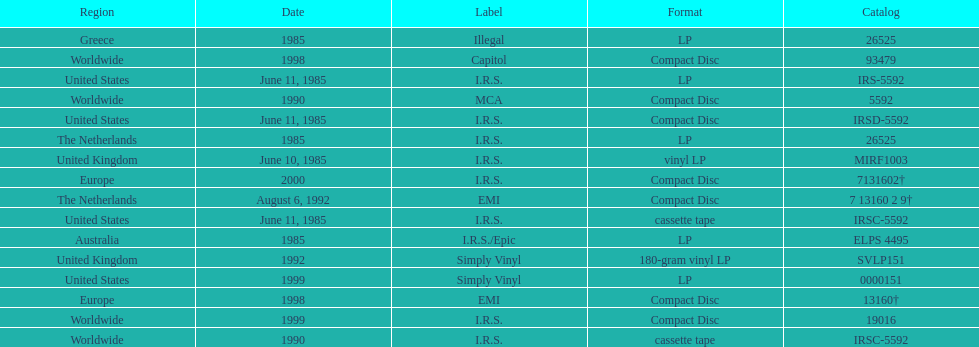What was the date of the first vinyl lp release? June 10, 1985. 